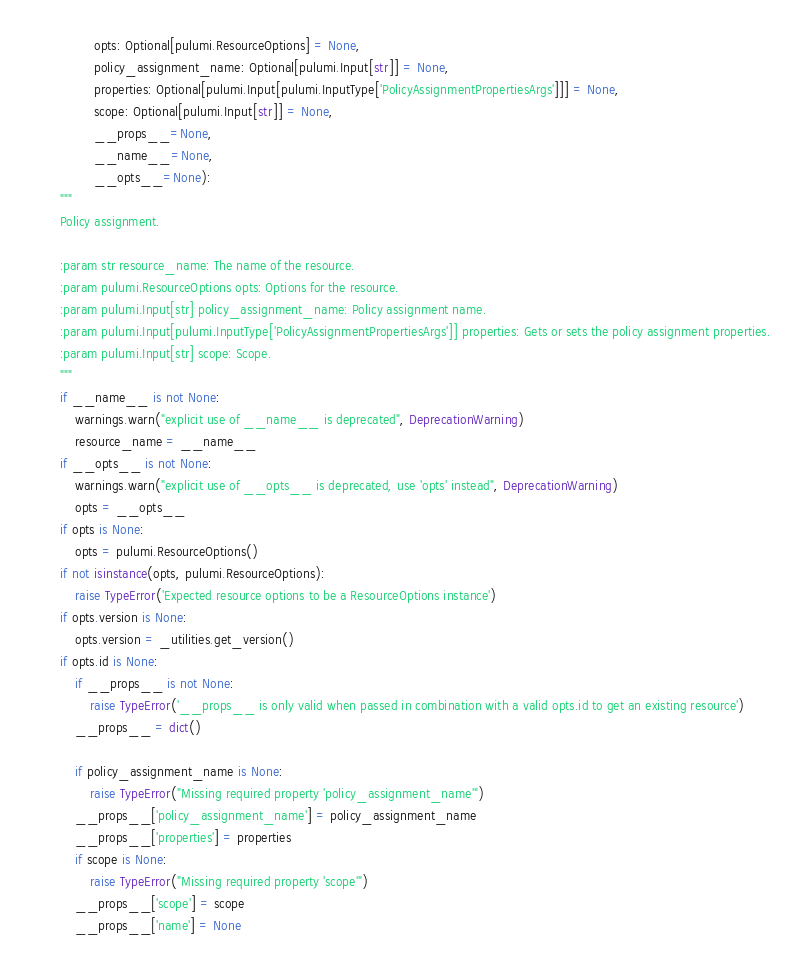<code> <loc_0><loc_0><loc_500><loc_500><_Python_>                 opts: Optional[pulumi.ResourceOptions] = None,
                 policy_assignment_name: Optional[pulumi.Input[str]] = None,
                 properties: Optional[pulumi.Input[pulumi.InputType['PolicyAssignmentPropertiesArgs']]] = None,
                 scope: Optional[pulumi.Input[str]] = None,
                 __props__=None,
                 __name__=None,
                 __opts__=None):
        """
        Policy assignment.

        :param str resource_name: The name of the resource.
        :param pulumi.ResourceOptions opts: Options for the resource.
        :param pulumi.Input[str] policy_assignment_name: Policy assignment name.
        :param pulumi.Input[pulumi.InputType['PolicyAssignmentPropertiesArgs']] properties: Gets or sets the policy assignment properties.
        :param pulumi.Input[str] scope: Scope.
        """
        if __name__ is not None:
            warnings.warn("explicit use of __name__ is deprecated", DeprecationWarning)
            resource_name = __name__
        if __opts__ is not None:
            warnings.warn("explicit use of __opts__ is deprecated, use 'opts' instead", DeprecationWarning)
            opts = __opts__
        if opts is None:
            opts = pulumi.ResourceOptions()
        if not isinstance(opts, pulumi.ResourceOptions):
            raise TypeError('Expected resource options to be a ResourceOptions instance')
        if opts.version is None:
            opts.version = _utilities.get_version()
        if opts.id is None:
            if __props__ is not None:
                raise TypeError('__props__ is only valid when passed in combination with a valid opts.id to get an existing resource')
            __props__ = dict()

            if policy_assignment_name is None:
                raise TypeError("Missing required property 'policy_assignment_name'")
            __props__['policy_assignment_name'] = policy_assignment_name
            __props__['properties'] = properties
            if scope is None:
                raise TypeError("Missing required property 'scope'")
            __props__['scope'] = scope
            __props__['name'] = None</code> 